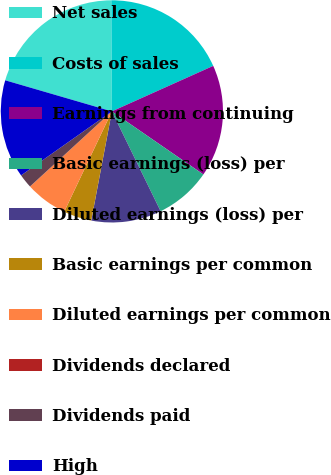<chart> <loc_0><loc_0><loc_500><loc_500><pie_chart><fcel>Net sales<fcel>Costs of sales<fcel>Earnings from continuing<fcel>Basic earnings (loss) per<fcel>Diluted earnings (loss) per<fcel>Basic earnings per common<fcel>Diluted earnings per common<fcel>Dividends declared<fcel>Dividends paid<fcel>High<nl><fcel>20.4%<fcel>18.36%<fcel>16.32%<fcel>8.16%<fcel>10.2%<fcel>4.08%<fcel>6.12%<fcel>0.01%<fcel>2.04%<fcel>14.28%<nl></chart> 